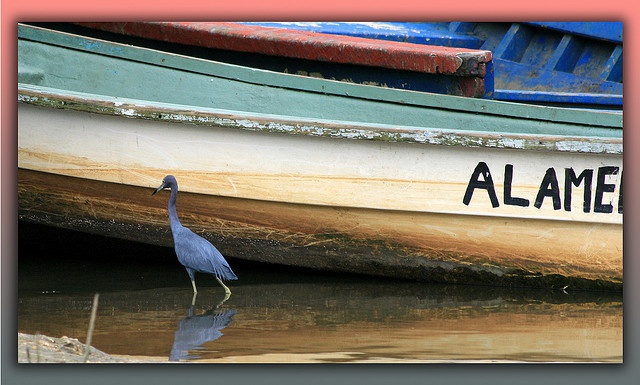Describe the objects in this image and their specific colors. I can see boat in pink, black, ivory, darkgray, and teal tones and bird in pink, gray, and black tones in this image. 